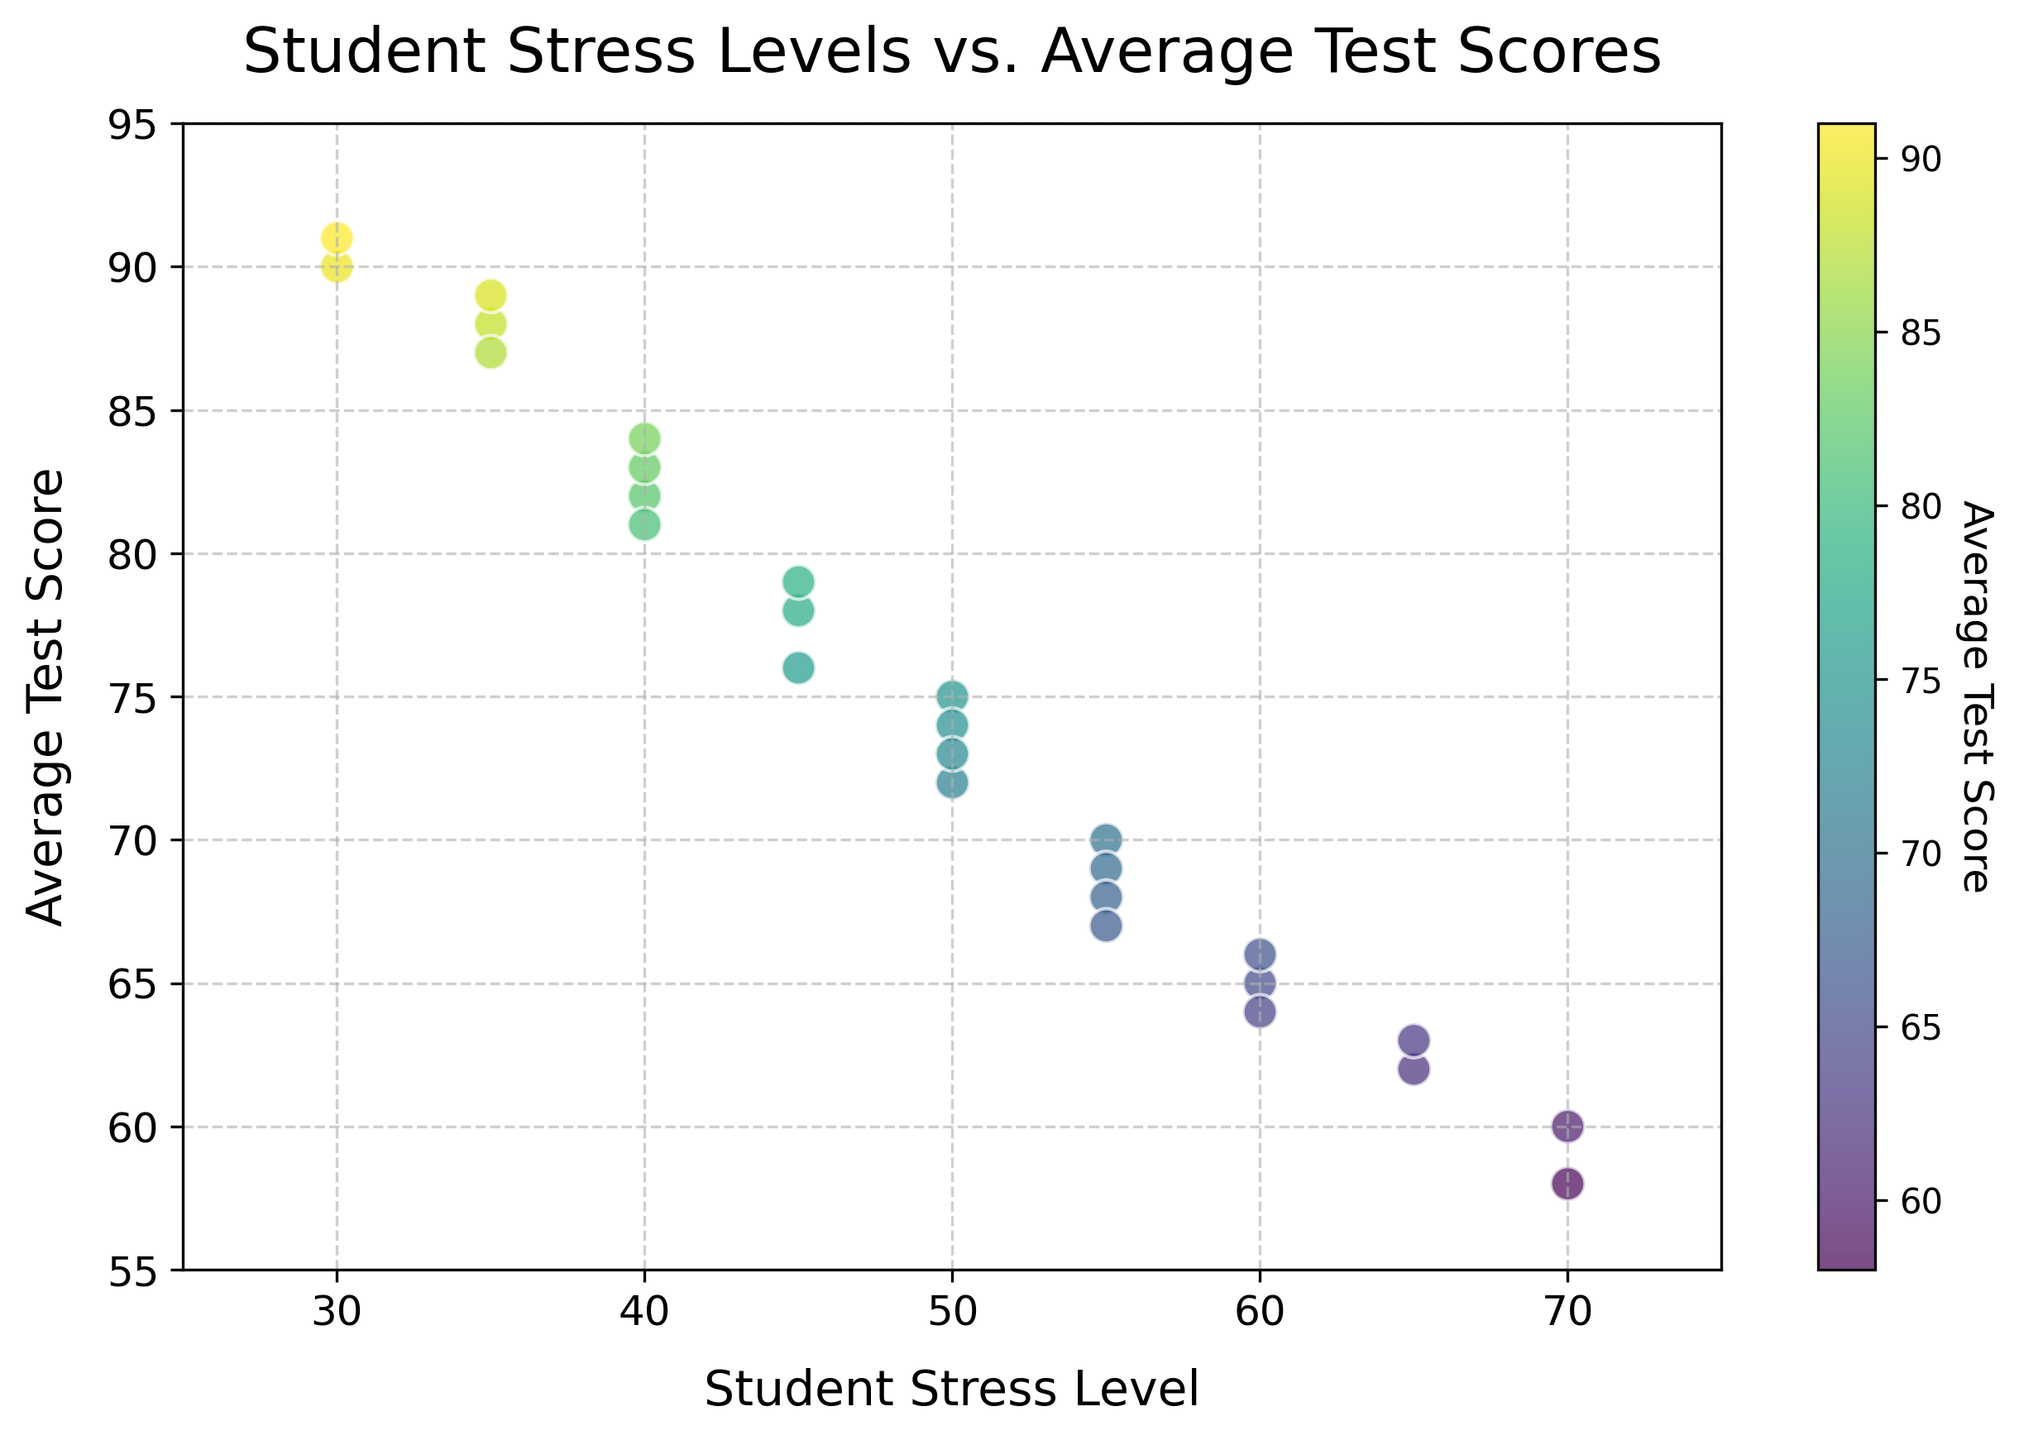What is the general trend between student stress levels and average test scores? By observing the plotted points, it is evident that as student stress levels increase, the average test scores tend to decrease. This negative correlation shows that higher stress levels are associated with lower test scores.
Answer: Negative correlation Which student has the highest average test score and what is their stress level? By locating the highest point on the y-axis, the student with the highest average test score has a score of 91. Then, by looking at the corresponding x-axis value, this student's stress level is 30.
Answer: Score: 91, Stress Level: 30 Is there a student with an average test score of 60? If yes, what is their stress level? By checking the y-axis for an average test score of 60 and finding the corresponding points, there are two students with this score. Their stress levels are 70.
Answer: Stress Level: 70 Do higher average test scores generally correspond to lighter or darker colors on the plot? By analyzing the color gradient represented by the color bar, higher average test scores correspond to lighter colors, while lower scores correspond to darker colors.
Answer: Lighter colors What is the range of average test scores for students with stress levels between 40 and 50? Observing the scatter plot, identify the points with stress levels between 40 and 50 and then check their corresponding y-values. The average test scores range from 73 to 84.
Answer: 73 to 84 Based on the plot, what visual pattern can you observe about students with low stress levels (30-35)? By focusing on the points with stress levels between 30 and 35, it is clear that these students generally have higher average test scores, clustered around the upper y-axis range.
Answer: Higher scores What is the difference in average test scores between the student with the lowest stress level and the student with the highest stress level? The student with the lowest stress level (30) has the highest score of 91. The student with the highest stress level (70) has scores of 58 and 60. Calculating the difference: 91 - 58 = 33 and 91 - 60 = 31.
Answer: 31 to 33 For stress levels above 60, what is the maximum average test score observed? By locating points with stress levels above 60 and observing their y-values, the maximum average test score among these students is 66.
Answer: 66 